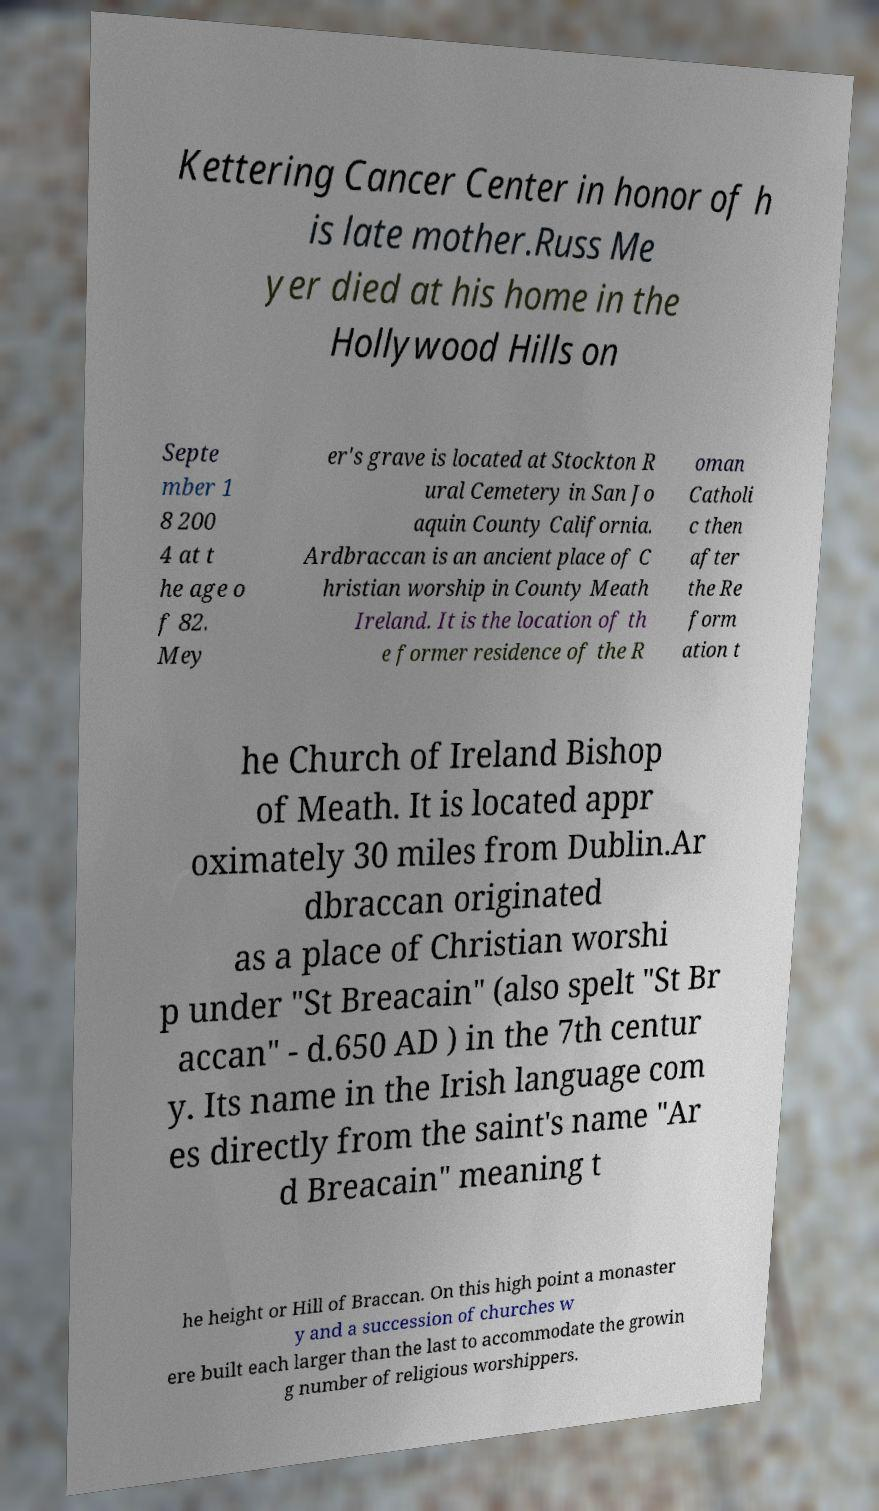Could you extract and type out the text from this image? Kettering Cancer Center in honor of h is late mother.Russ Me yer died at his home in the Hollywood Hills on Septe mber 1 8 200 4 at t he age o f 82. Mey er's grave is located at Stockton R ural Cemetery in San Jo aquin County California. Ardbraccan is an ancient place of C hristian worship in County Meath Ireland. It is the location of th e former residence of the R oman Catholi c then after the Re form ation t he Church of Ireland Bishop of Meath. It is located appr oximately 30 miles from Dublin.Ar dbraccan originated as a place of Christian worshi p under "St Breacain" (also spelt "St Br accan" - d.650 AD ) in the 7th centur y. Its name in the Irish language com es directly from the saint's name "Ar d Breacain" meaning t he height or Hill of Braccan. On this high point a monaster y and a succession of churches w ere built each larger than the last to accommodate the growin g number of religious worshippers. 